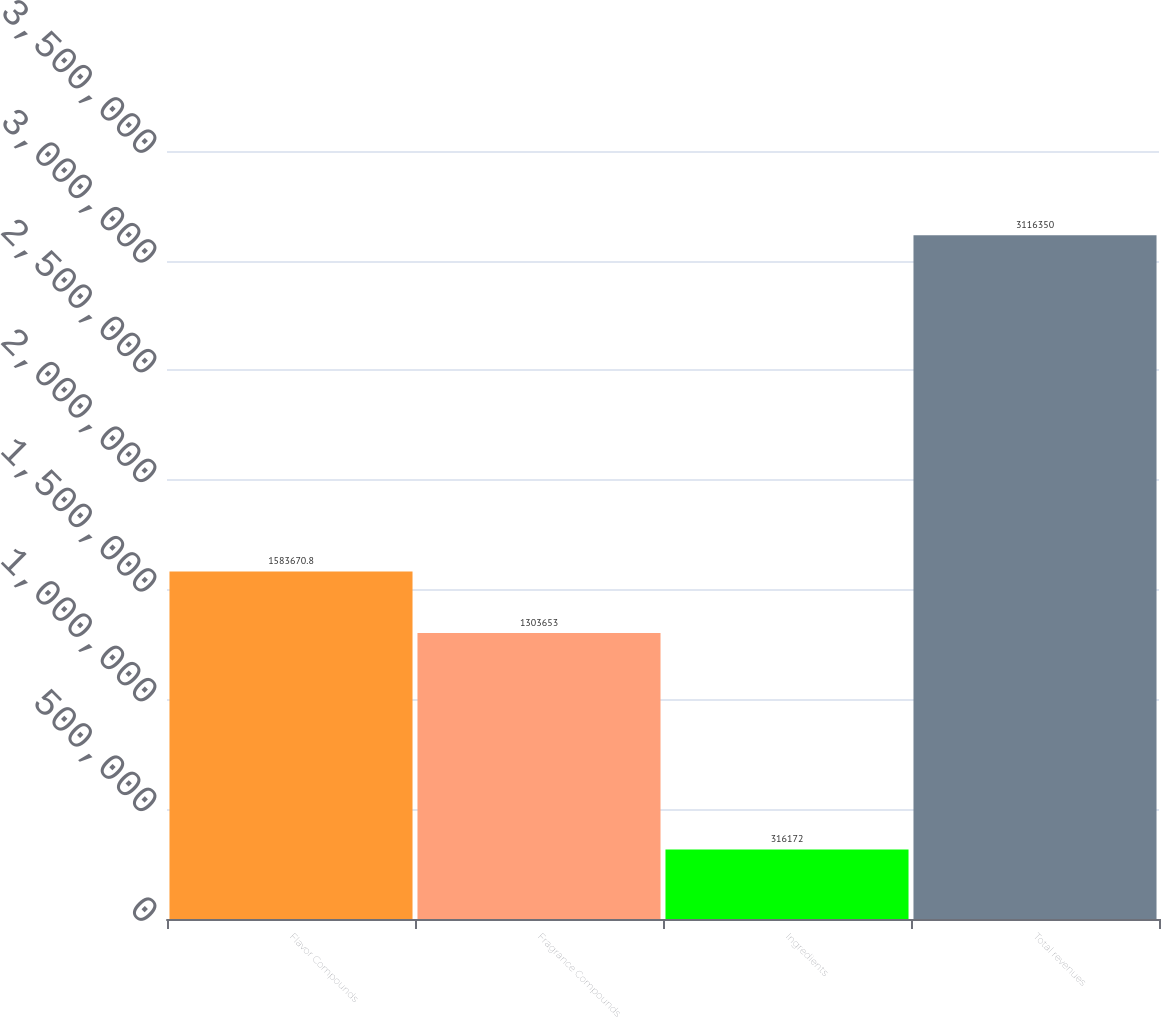<chart> <loc_0><loc_0><loc_500><loc_500><bar_chart><fcel>Flavor Compounds<fcel>Fragrance Compounds<fcel>Ingredients<fcel>Total revenues<nl><fcel>1.58367e+06<fcel>1.30365e+06<fcel>316172<fcel>3.11635e+06<nl></chart> 